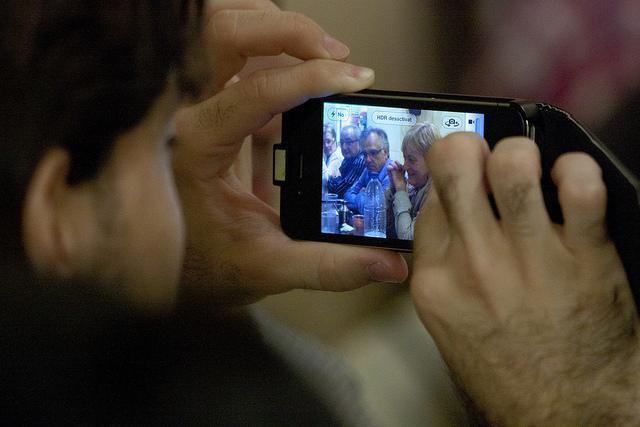Which is magnifying or moving towards yourself the photography is called?
Answer the question by selecting the correct answer among the 4 following choices and explain your choice with a short sentence. The answer should be formatted with the following format: `Answer: choice
Rationale: rationale.`
Options: None, scroll, zoom, move. Answer: zoom.
Rationale: The zoom is magnifying. 